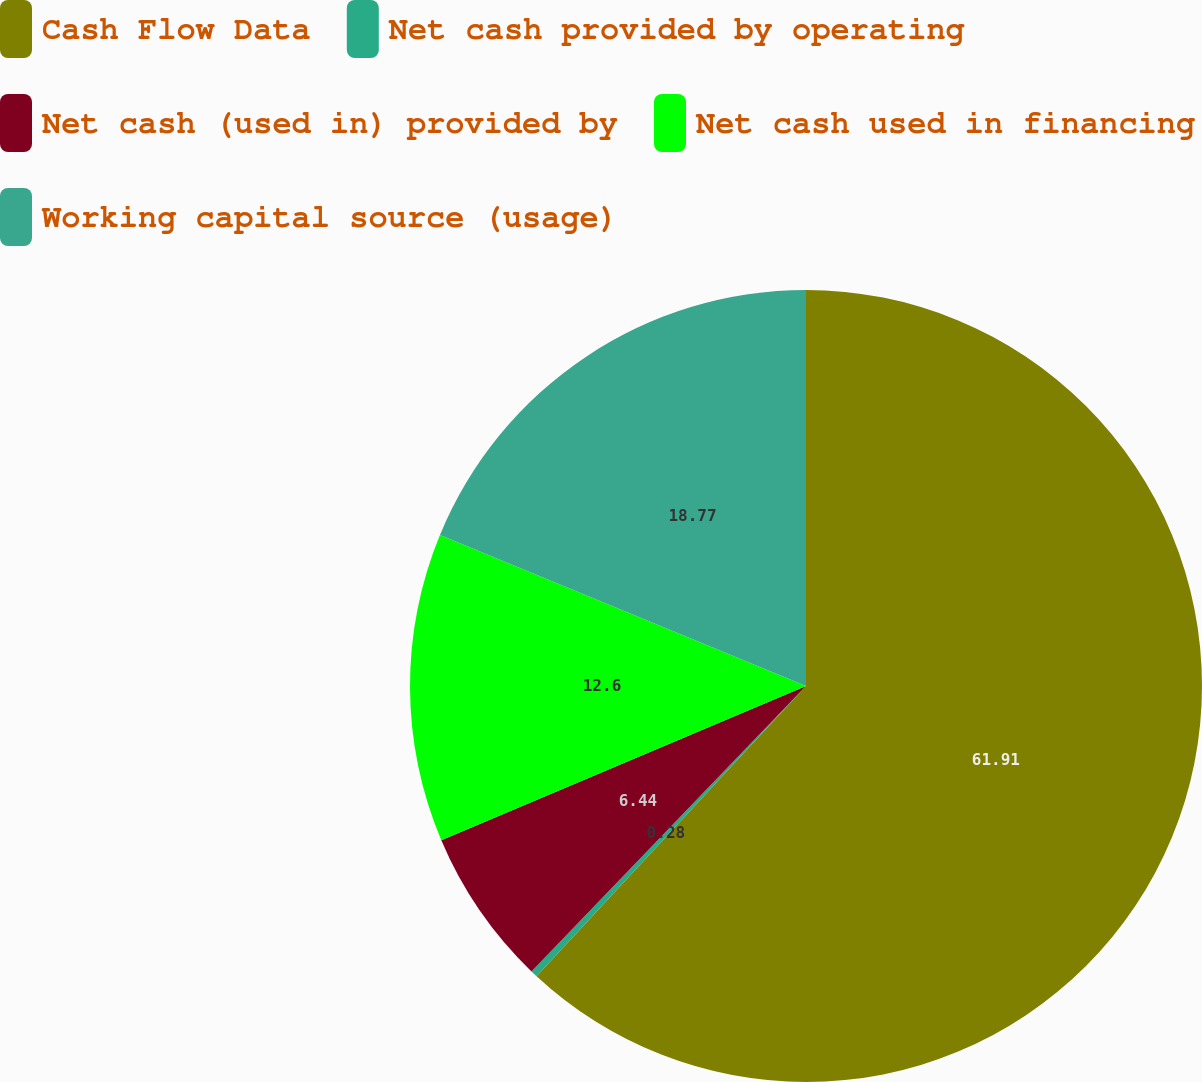Convert chart to OTSL. <chart><loc_0><loc_0><loc_500><loc_500><pie_chart><fcel>Cash Flow Data<fcel>Net cash provided by operating<fcel>Net cash (used in) provided by<fcel>Net cash used in financing<fcel>Working capital source (usage)<nl><fcel>61.91%<fcel>0.28%<fcel>6.44%<fcel>12.6%<fcel>18.77%<nl></chart> 